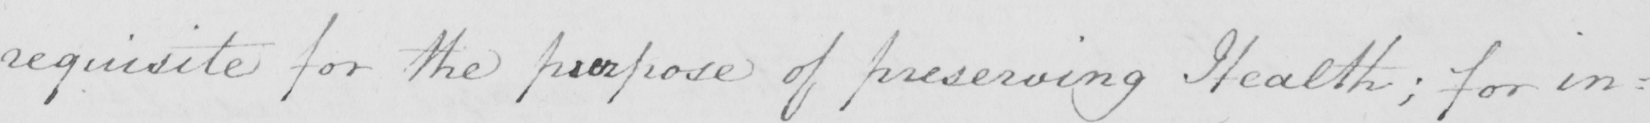Can you tell me what this handwritten text says? requisite for the purpose of preserving Health ; for in= 